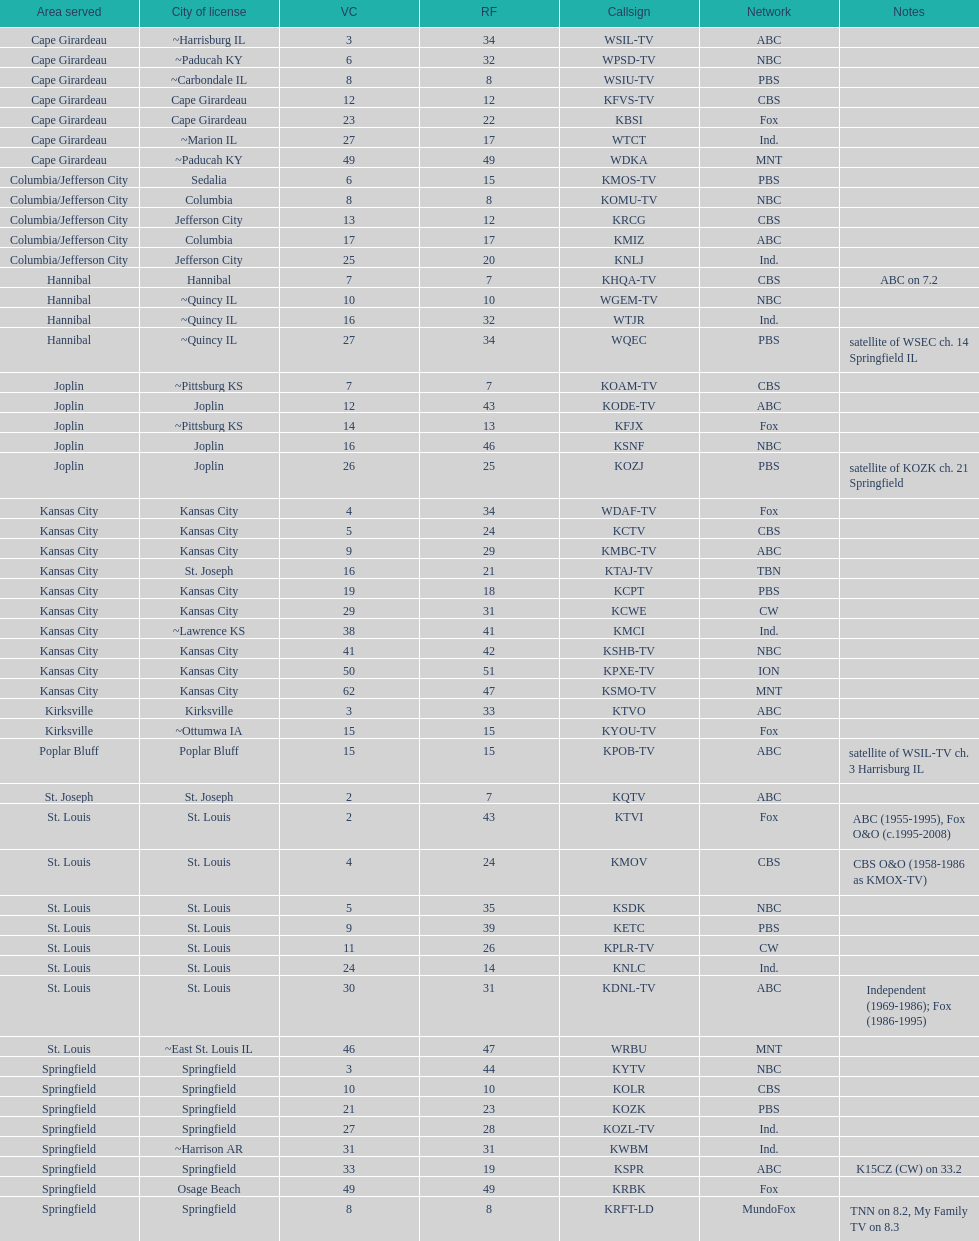How many of these missouri tv stations are actually licensed in a city in illinois (il)? 7. 